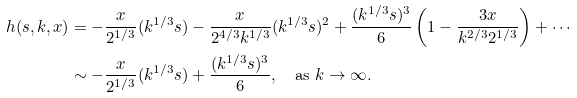<formula> <loc_0><loc_0><loc_500><loc_500>h ( s , k , x ) & = - \frac { x } { 2 ^ { 1 / 3 } } ( k ^ { 1 / 3 } s ) - \frac { x } { 2 ^ { 4 / 3 } k ^ { 1 / 3 } } ( k ^ { 1 / 3 } s ) ^ { 2 } + \frac { ( k ^ { 1 / 3 } s ) ^ { 3 } } 6 \left ( 1 - \frac { 3 x } { k ^ { 2 / 3 } 2 ^ { 1 / 3 } } \right ) + \cdots \\ & \sim - \frac { x } { 2 ^ { 1 / 3 } } ( k ^ { 1 / 3 } s ) + \frac { ( k ^ { 1 / 3 } s ) ^ { 3 } } 6 , \quad \text {as $k\to\infty$} .</formula> 